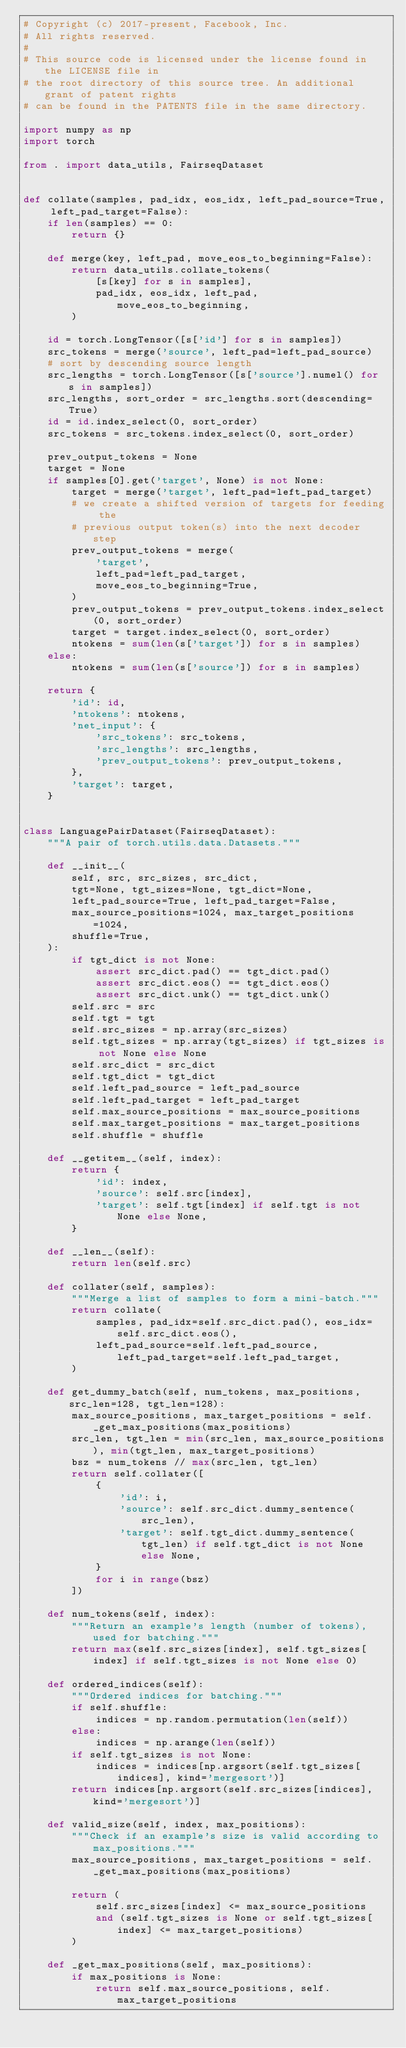<code> <loc_0><loc_0><loc_500><loc_500><_Python_># Copyright (c) 2017-present, Facebook, Inc.
# All rights reserved.
#
# This source code is licensed under the license found in the LICENSE file in
# the root directory of this source tree. An additional grant of patent rights
# can be found in the PATENTS file in the same directory.

import numpy as np
import torch

from . import data_utils, FairseqDataset


def collate(samples, pad_idx, eos_idx, left_pad_source=True, left_pad_target=False):
    if len(samples) == 0:
        return {}

    def merge(key, left_pad, move_eos_to_beginning=False):
        return data_utils.collate_tokens(
            [s[key] for s in samples],
            pad_idx, eos_idx, left_pad, move_eos_to_beginning,
        )

    id = torch.LongTensor([s['id'] for s in samples])
    src_tokens = merge('source', left_pad=left_pad_source)
    # sort by descending source length
    src_lengths = torch.LongTensor([s['source'].numel() for s in samples])
    src_lengths, sort_order = src_lengths.sort(descending=True)
    id = id.index_select(0, sort_order)
    src_tokens = src_tokens.index_select(0, sort_order)

    prev_output_tokens = None
    target = None
    if samples[0].get('target', None) is not None:
        target = merge('target', left_pad=left_pad_target)
        # we create a shifted version of targets for feeding the
        # previous output token(s) into the next decoder step
        prev_output_tokens = merge(
            'target',
            left_pad=left_pad_target,
            move_eos_to_beginning=True,
        )
        prev_output_tokens = prev_output_tokens.index_select(0, sort_order)
        target = target.index_select(0, sort_order)
        ntokens = sum(len(s['target']) for s in samples)
    else:
        ntokens = sum(len(s['source']) for s in samples)

    return {
        'id': id,
        'ntokens': ntokens,
        'net_input': {
            'src_tokens': src_tokens,
            'src_lengths': src_lengths,
            'prev_output_tokens': prev_output_tokens,
        },
        'target': target,
    }


class LanguagePairDataset(FairseqDataset):
    """A pair of torch.utils.data.Datasets."""

    def __init__(
        self, src, src_sizes, src_dict,
        tgt=None, tgt_sizes=None, tgt_dict=None,
        left_pad_source=True, left_pad_target=False,
        max_source_positions=1024, max_target_positions=1024,
        shuffle=True,
    ):
        if tgt_dict is not None:
            assert src_dict.pad() == tgt_dict.pad()
            assert src_dict.eos() == tgt_dict.eos()
            assert src_dict.unk() == tgt_dict.unk()
        self.src = src
        self.tgt = tgt
        self.src_sizes = np.array(src_sizes)
        self.tgt_sizes = np.array(tgt_sizes) if tgt_sizes is not None else None
        self.src_dict = src_dict
        self.tgt_dict = tgt_dict
        self.left_pad_source = left_pad_source
        self.left_pad_target = left_pad_target
        self.max_source_positions = max_source_positions
        self.max_target_positions = max_target_positions
        self.shuffle = shuffle

    def __getitem__(self, index):
        return {
            'id': index,
            'source': self.src[index],
            'target': self.tgt[index] if self.tgt is not None else None,
        }

    def __len__(self):
        return len(self.src)

    def collater(self, samples):
        """Merge a list of samples to form a mini-batch."""
        return collate(
            samples, pad_idx=self.src_dict.pad(), eos_idx=self.src_dict.eos(),
            left_pad_source=self.left_pad_source, left_pad_target=self.left_pad_target,
        )

    def get_dummy_batch(self, num_tokens, max_positions, src_len=128, tgt_len=128):
        max_source_positions, max_target_positions = self._get_max_positions(max_positions)
        src_len, tgt_len = min(src_len, max_source_positions), min(tgt_len, max_target_positions)
        bsz = num_tokens // max(src_len, tgt_len)
        return self.collater([
            {
                'id': i,
                'source': self.src_dict.dummy_sentence(src_len),
                'target': self.tgt_dict.dummy_sentence(tgt_len) if self.tgt_dict is not None else None,
            }
            for i in range(bsz)
        ])

    def num_tokens(self, index):
        """Return an example's length (number of tokens), used for batching."""
        return max(self.src_sizes[index], self.tgt_sizes[index] if self.tgt_sizes is not None else 0)

    def ordered_indices(self):
        """Ordered indices for batching."""
        if self.shuffle:
            indices = np.random.permutation(len(self))
        else:
            indices = np.arange(len(self))
        if self.tgt_sizes is not None:
            indices = indices[np.argsort(self.tgt_sizes[indices], kind='mergesort')]
        return indices[np.argsort(self.src_sizes[indices], kind='mergesort')]

    def valid_size(self, index, max_positions):
        """Check if an example's size is valid according to max_positions."""
        max_source_positions, max_target_positions = self._get_max_positions(max_positions)

        return (
            self.src_sizes[index] <= max_source_positions
            and (self.tgt_sizes is None or self.tgt_sizes[index] <= max_target_positions)
        )

    def _get_max_positions(self, max_positions):
        if max_positions is None:
            return self.max_source_positions, self.max_target_positions</code> 